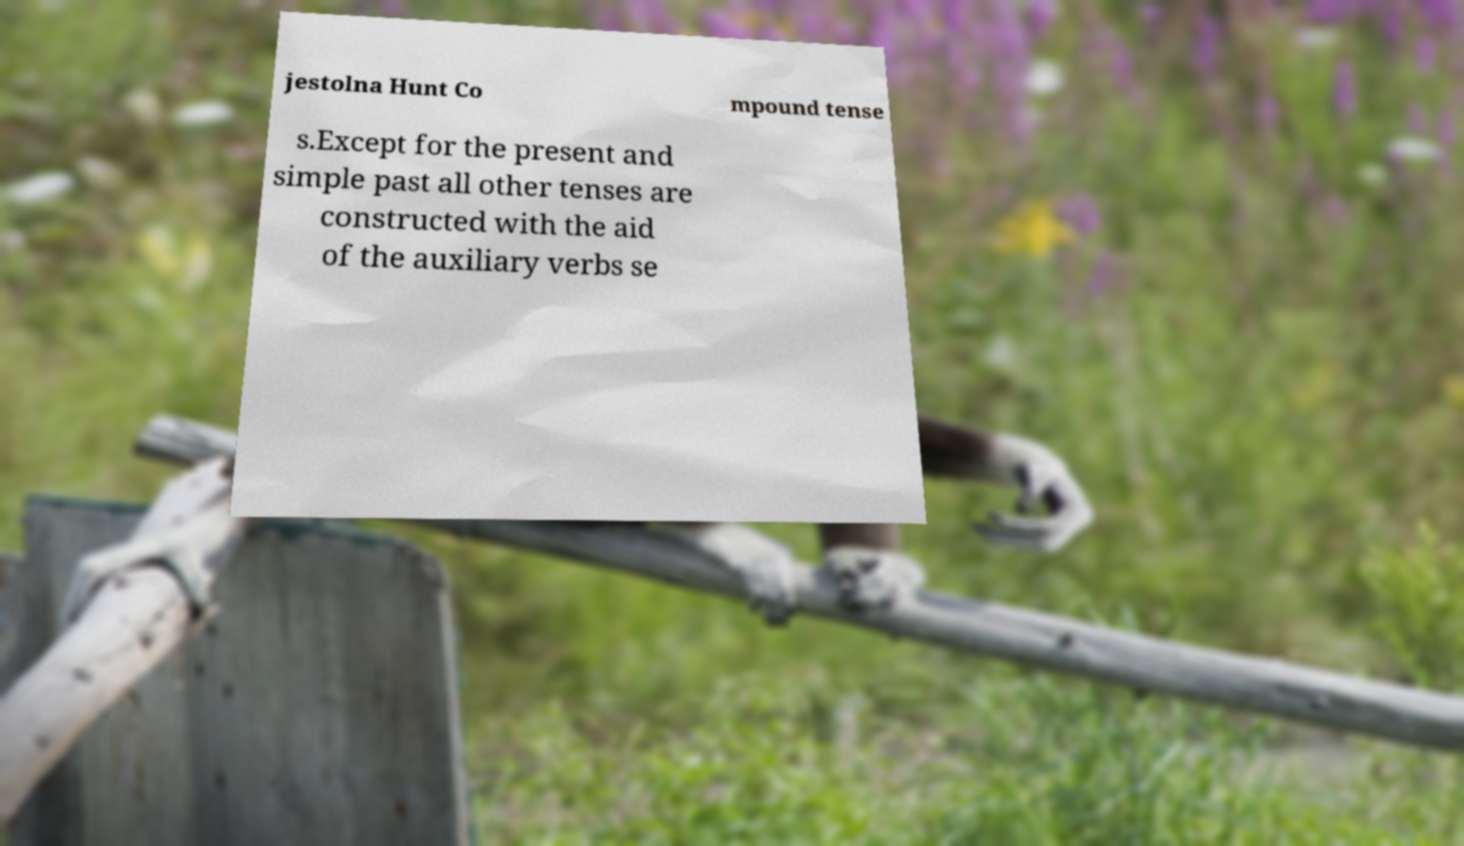For documentation purposes, I need the text within this image transcribed. Could you provide that? jestolna Hunt Co mpound tense s.Except for the present and simple past all other tenses are constructed with the aid of the auxiliary verbs se 